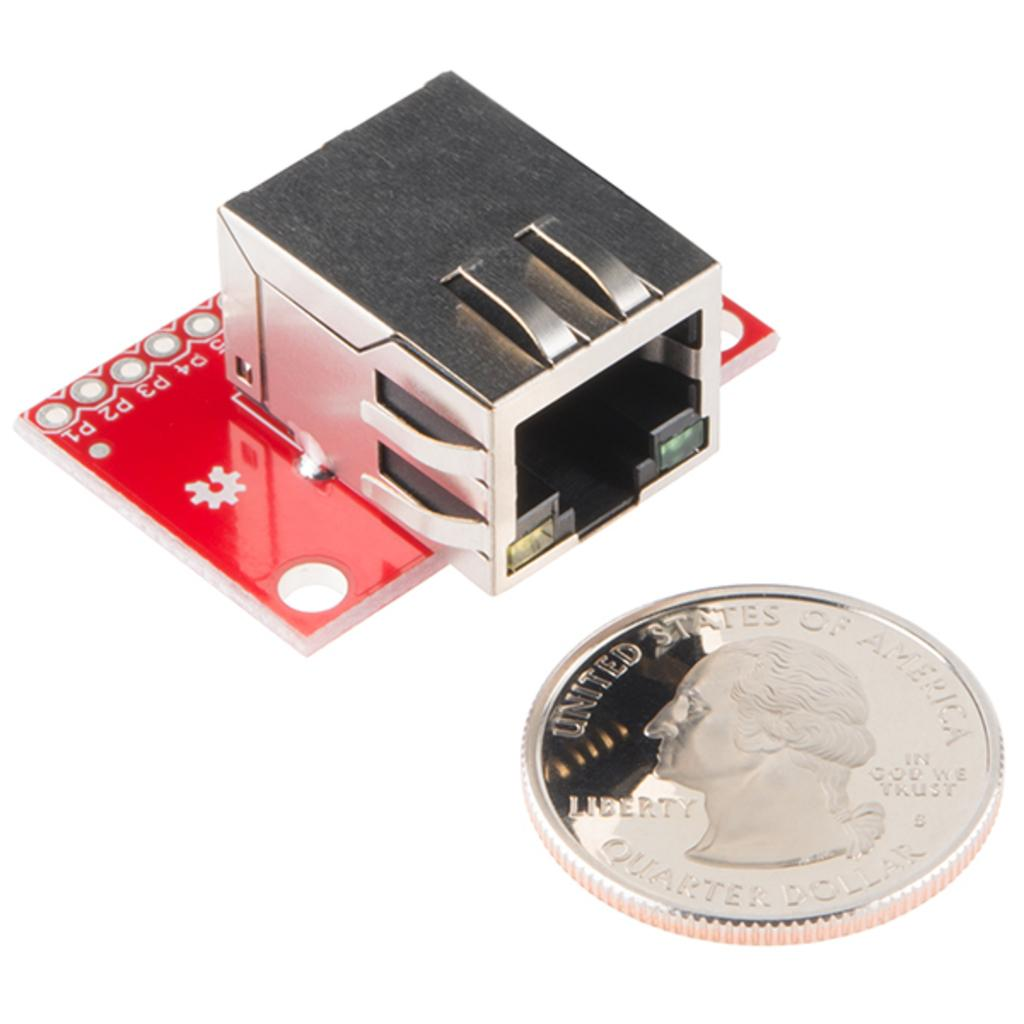<image>
Relay a brief, clear account of the picture shown. Change collector with a 25 cent Quarter being displayed. 